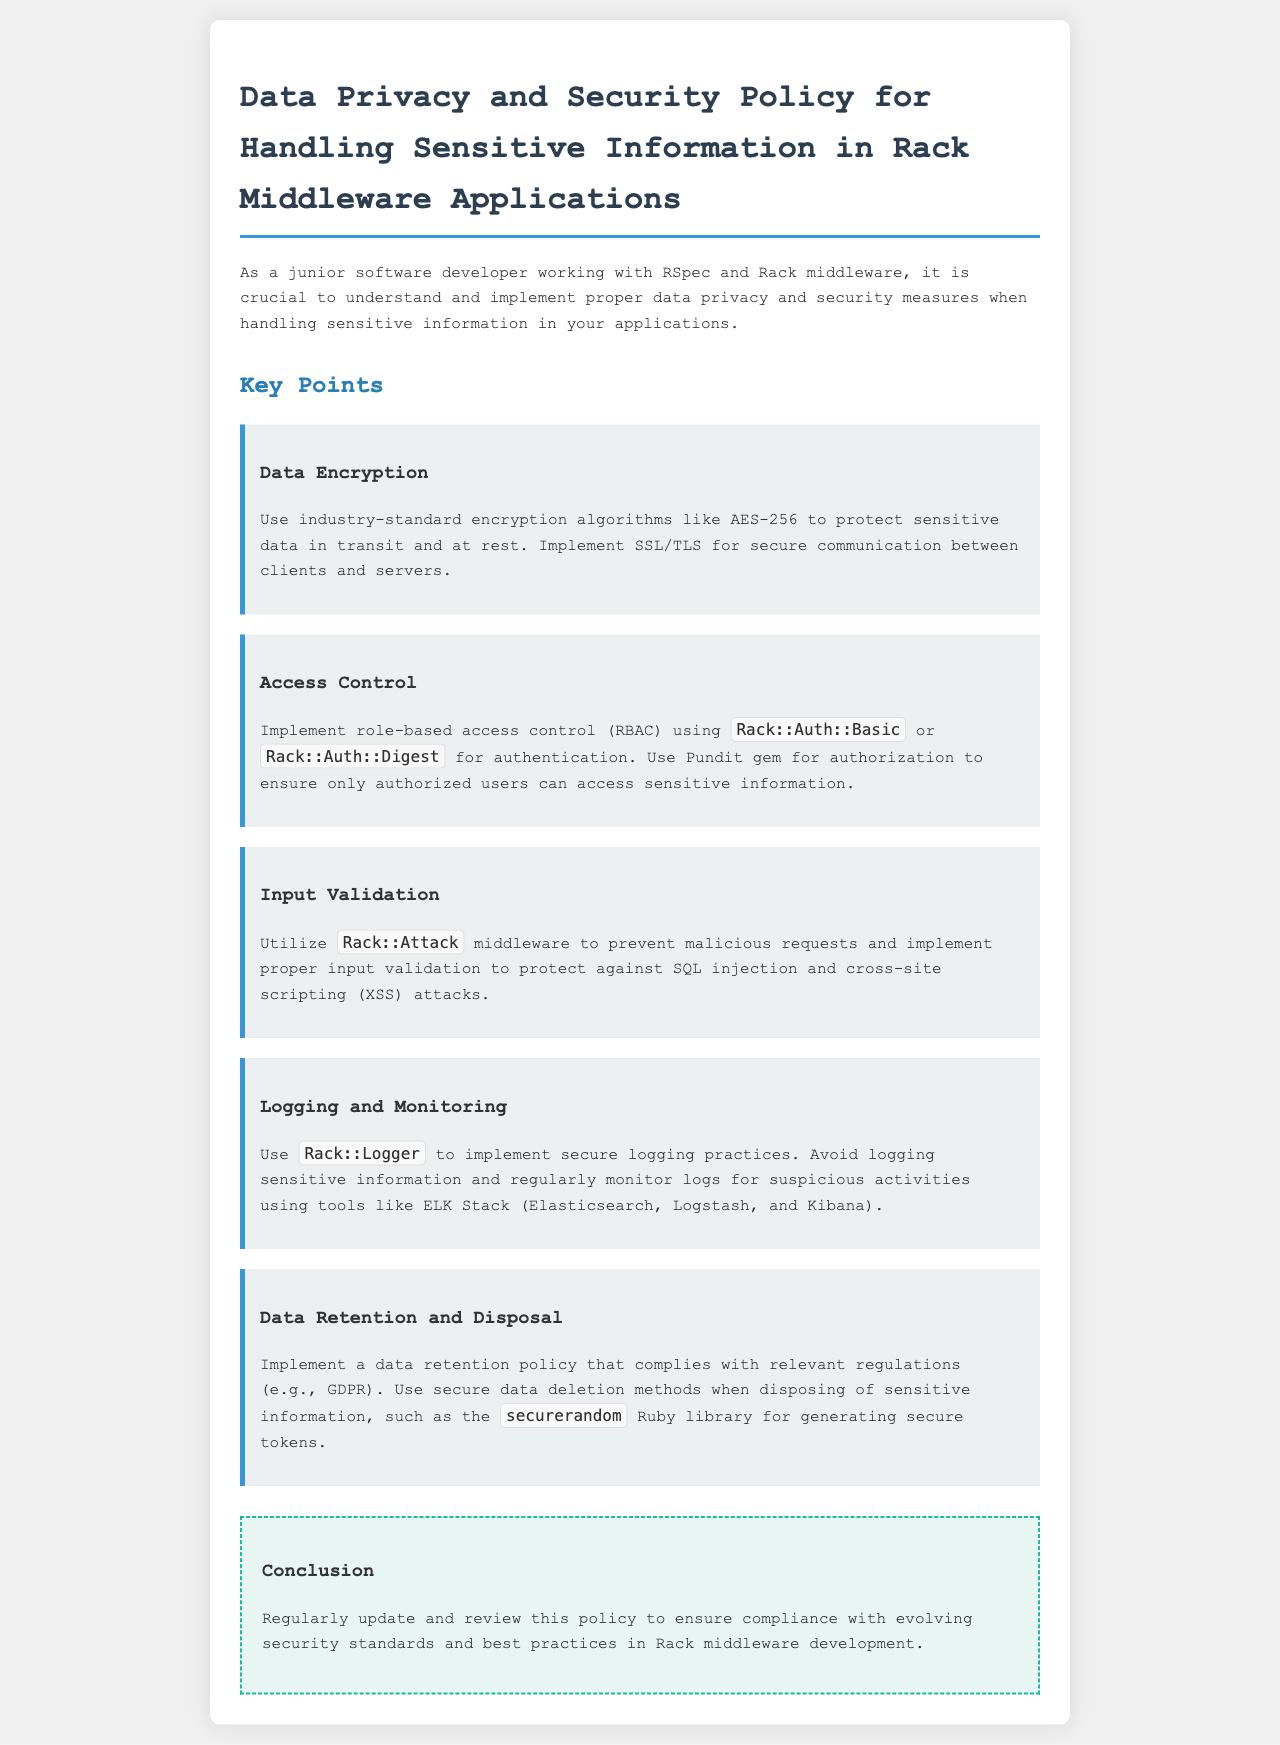What algorithm is recommended for data encryption? The document specifies using industry-standard encryption algorithms, highlighting AES-256 specifically for data encryption.
Answer: AES-256 What middleware is suggested for preventing malicious requests? The document mentions using specific middleware to protect against malicious requests, identifying Rack::Attack as the recommended option.
Answer: Rack::Attack Which gem is used for authorization? The document refers to a specific gem that aids in authorization, which is Pundit.
Answer: Pundit What should be avoided in logging practices? The key point on secure logging practices indicates that sensitive information should not be logged.
Answer: Sensitive information What method is mentioned for secure data deletion? The document advises using a specific Ruby library for generating secure tokens as part of secure data deletion practices, which is the securerandom library.
Answer: securerandom 